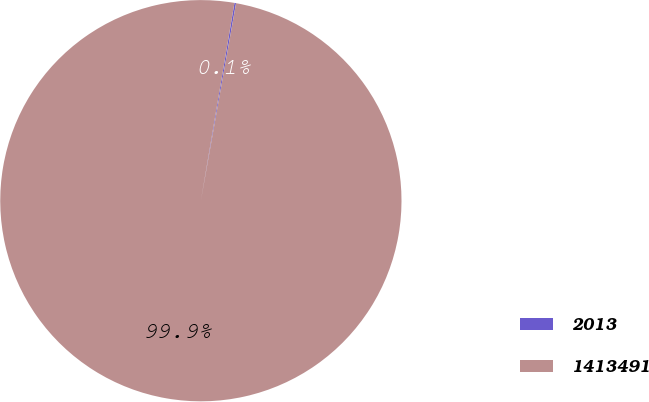Convert chart to OTSL. <chart><loc_0><loc_0><loc_500><loc_500><pie_chart><fcel>2013<fcel>1413491<nl><fcel>0.13%<fcel>99.87%<nl></chart> 